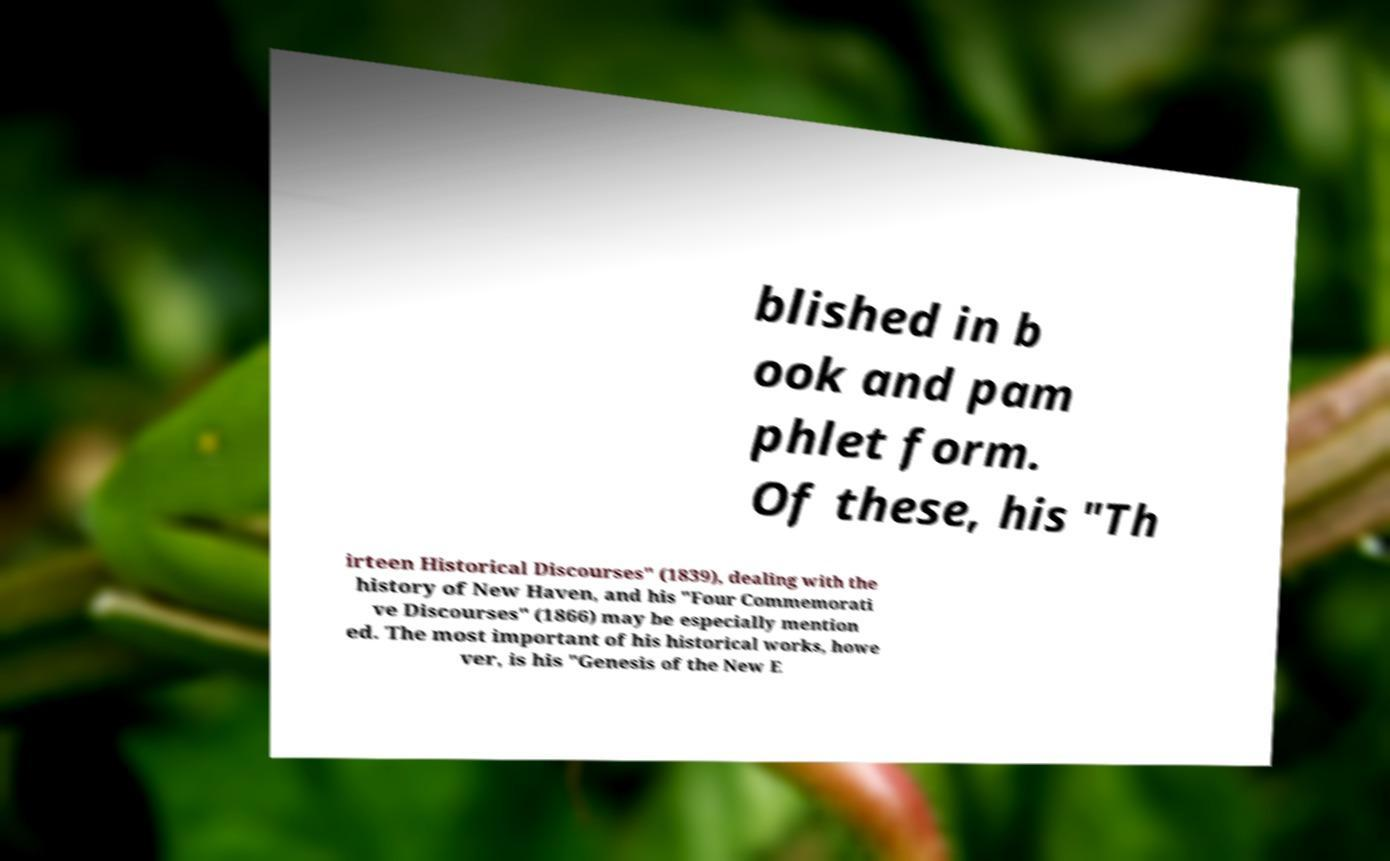Please read and relay the text visible in this image. What does it say? blished in b ook and pam phlet form. Of these, his "Th irteen Historical Discourses" (1839), dealing with the history of New Haven, and his "Four Commemorati ve Discourses" (1866) may be especially mention ed. The most important of his historical works, howe ver, is his "Genesis of the New E 